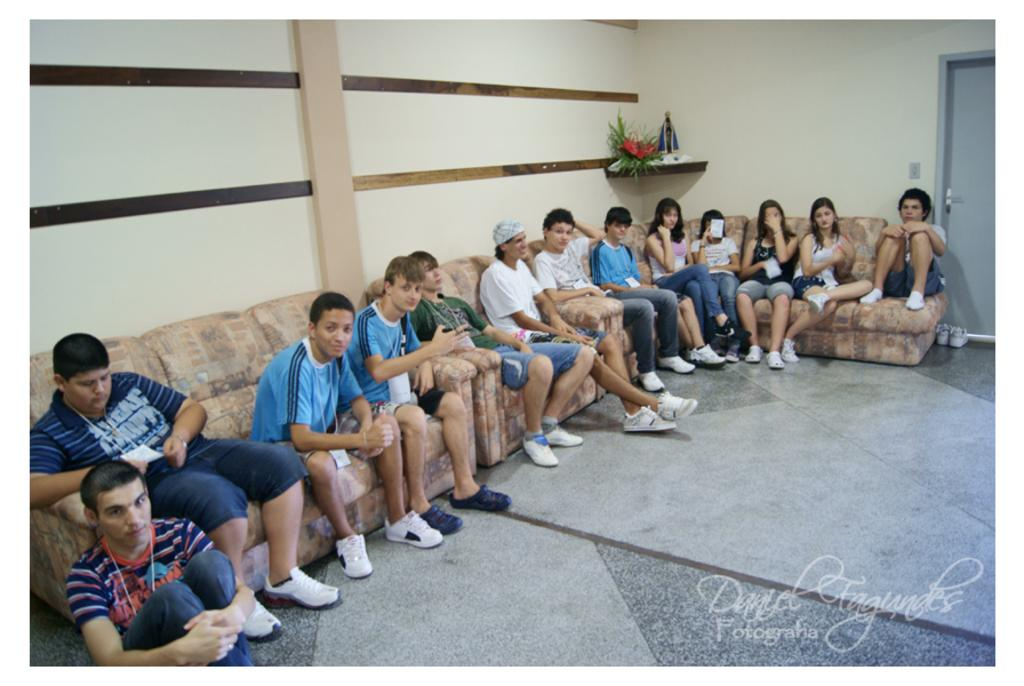How many people are in the image? There is a group of people in the image. What are the people doing in the image? The people are sitting on sofas. Is there anyone sitting on the floor in the image? Yes, there is a man sitting on the floor. What can be seen in the background of the image? There is a wall, a door, and shoes in the background of the image. What type of education can be seen in the image? There is no indication of education in the image; it features a group of people sitting on sofas and a man sitting on the floor. Can you tell me how many jellyfish are swimming in the image? There are no jellyfish present in the image. 